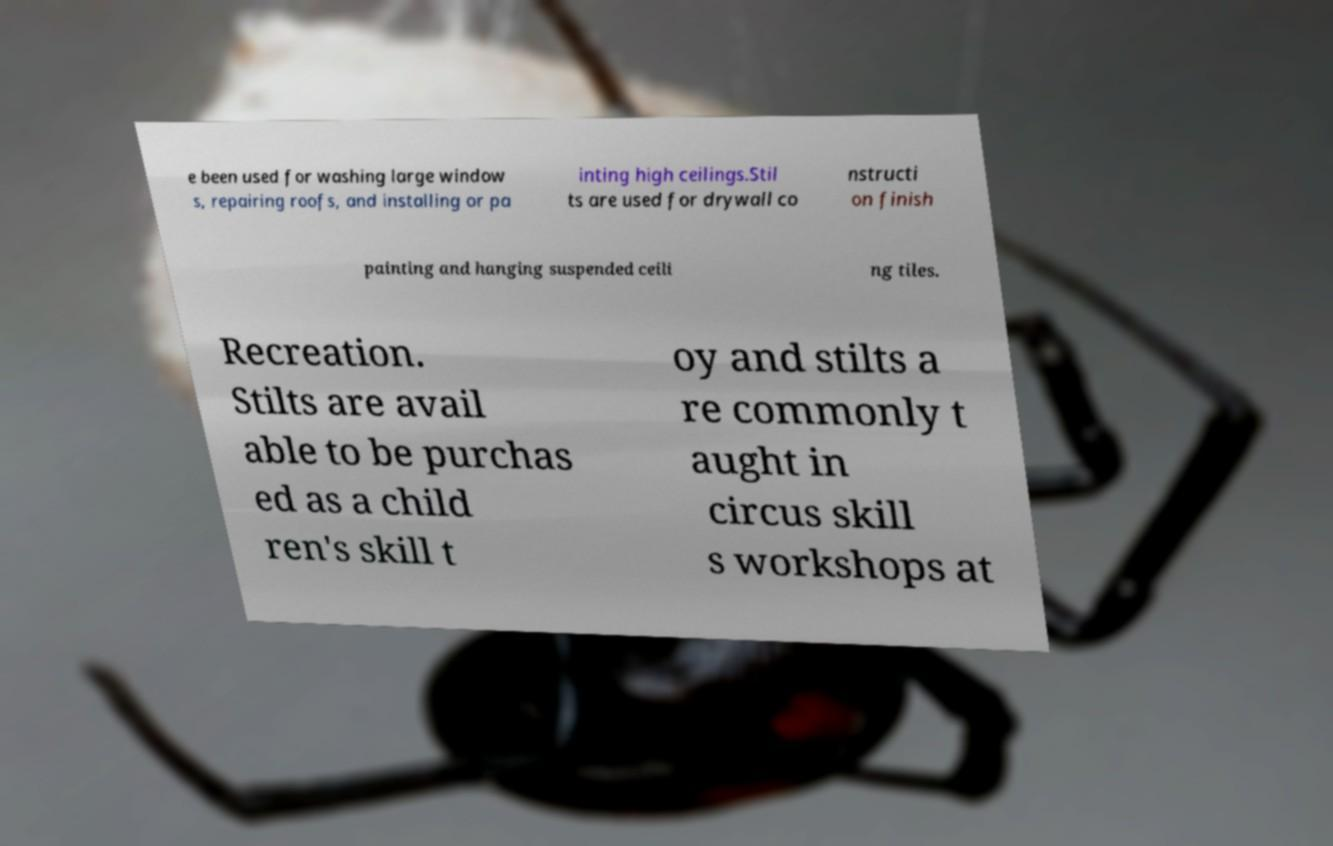I need the written content from this picture converted into text. Can you do that? e been used for washing large window s, repairing roofs, and installing or pa inting high ceilings.Stil ts are used for drywall co nstructi on finish painting and hanging suspended ceili ng tiles. Recreation. Stilts are avail able to be purchas ed as a child ren's skill t oy and stilts a re commonly t aught in circus skill s workshops at 